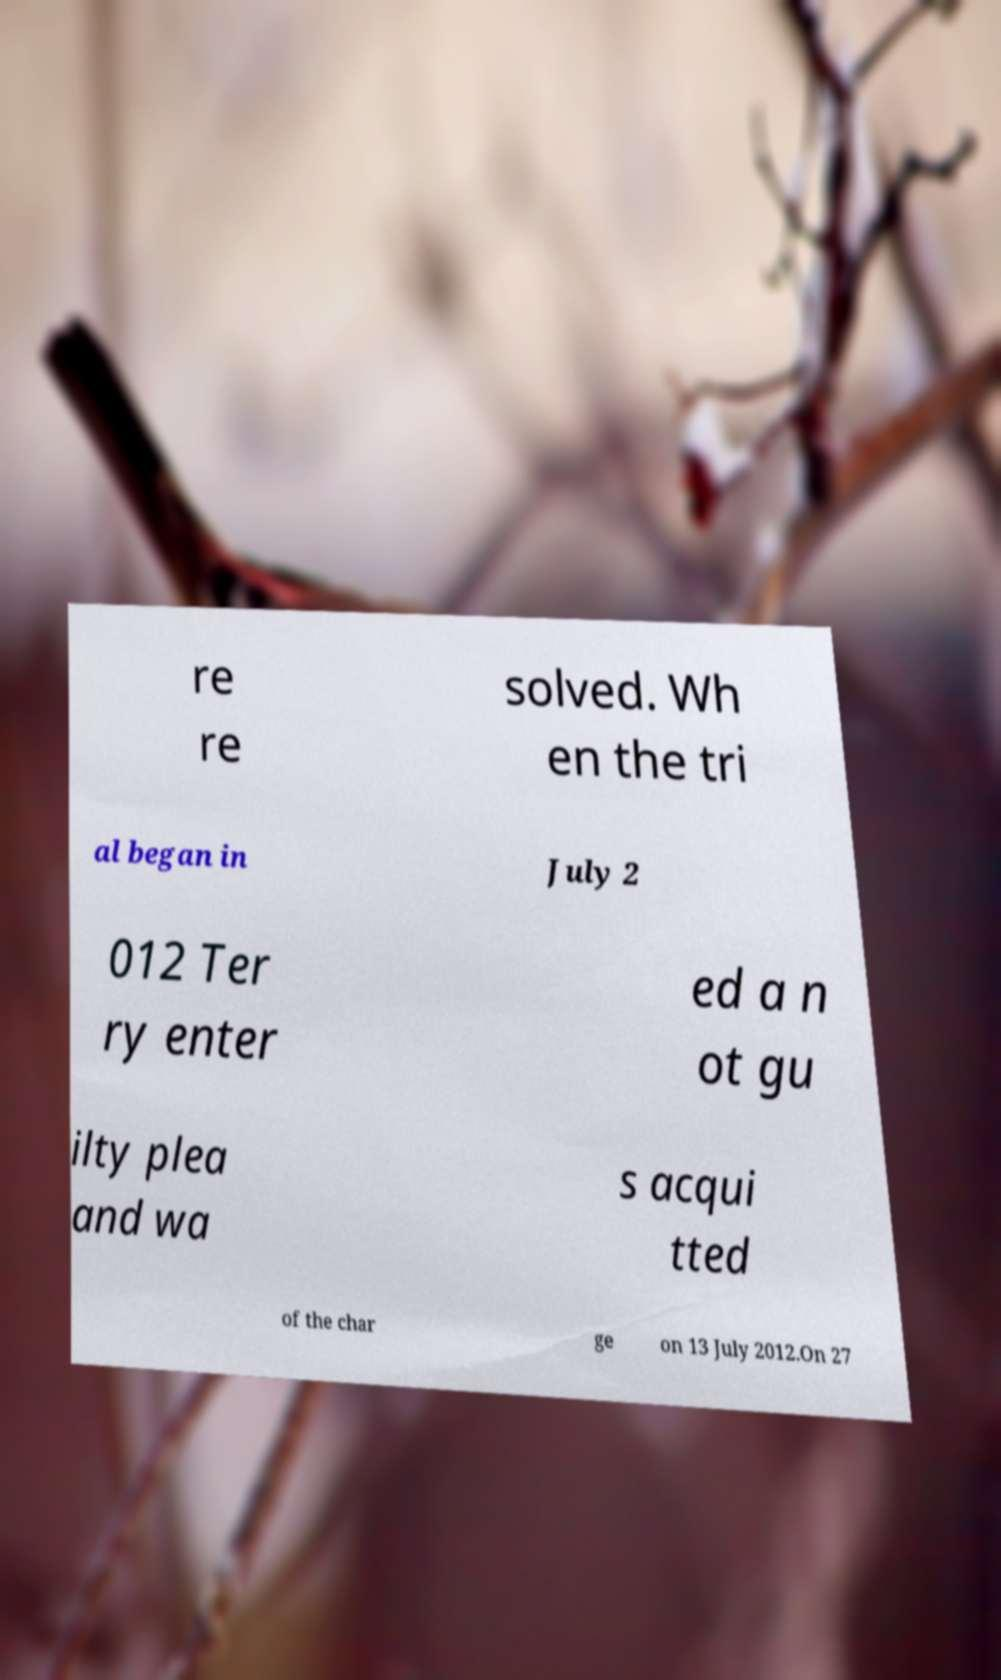I need the written content from this picture converted into text. Can you do that? re re solved. Wh en the tri al began in July 2 012 Ter ry enter ed a n ot gu ilty plea and wa s acqui tted of the char ge on 13 July 2012.On 27 